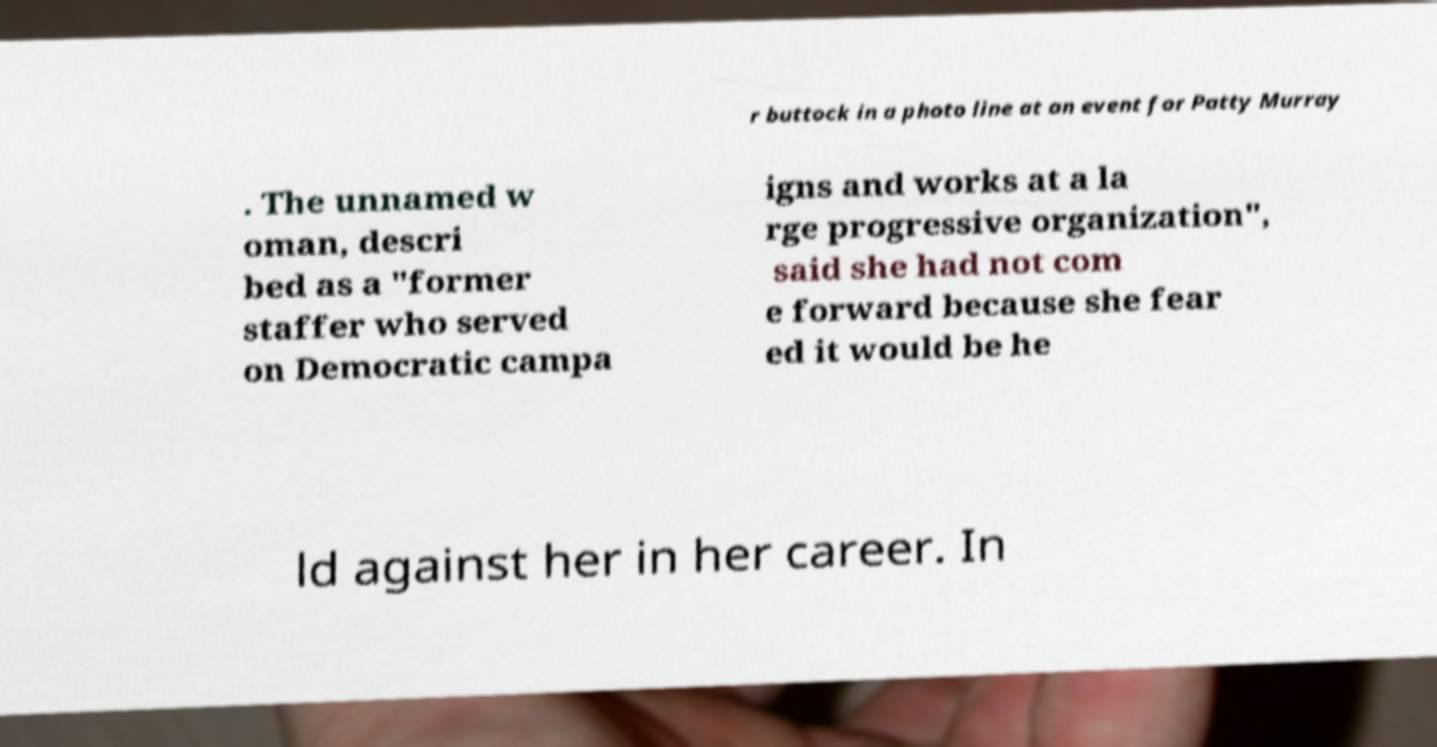Could you assist in decoding the text presented in this image and type it out clearly? r buttock in a photo line at an event for Patty Murray . The unnamed w oman, descri bed as a "former staffer who served on Democratic campa igns and works at a la rge progressive organization", said she had not com e forward because she fear ed it would be he ld against her in her career. In 